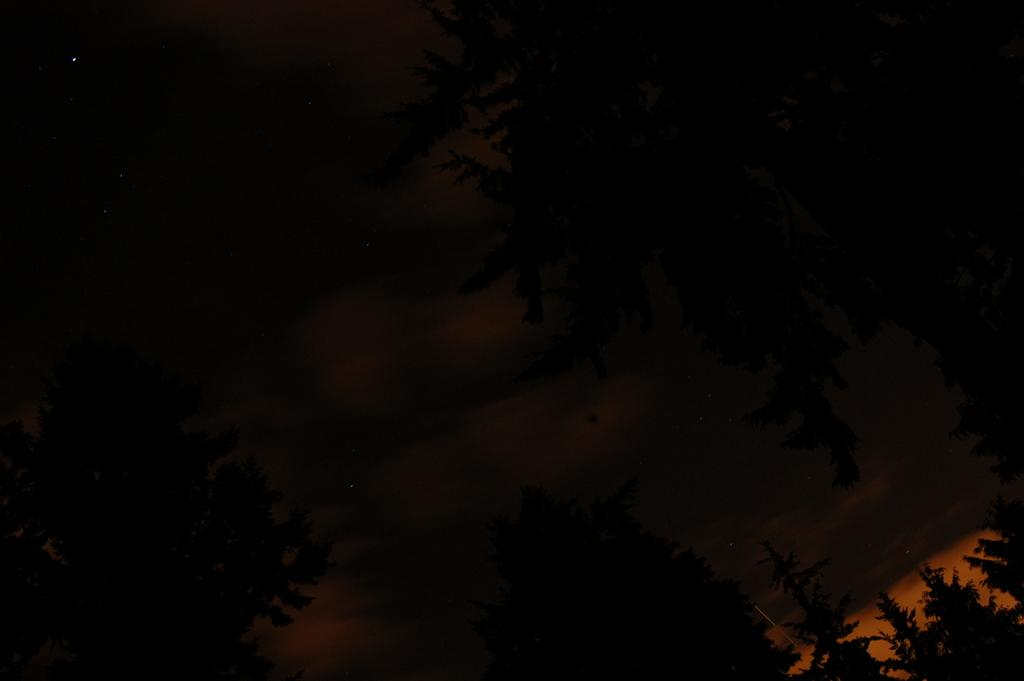What type of vegetation can be seen in the image? There are trees in the image. What is the condition of the sky in the image? The sky in the image is dark and appears to be during the night. Can you see a snake slithering through the trees in the image? There is no snake present in the image. What type of feast is being held under the trees in the image? There is no feast or gathering depicted in the image; it only shows trees and a dark sky. 